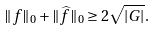<formula> <loc_0><loc_0><loc_500><loc_500>\| f \| _ { 0 } + \| \widehat { f } \| _ { 0 } \geq 2 \sqrt { | G | } .</formula> 